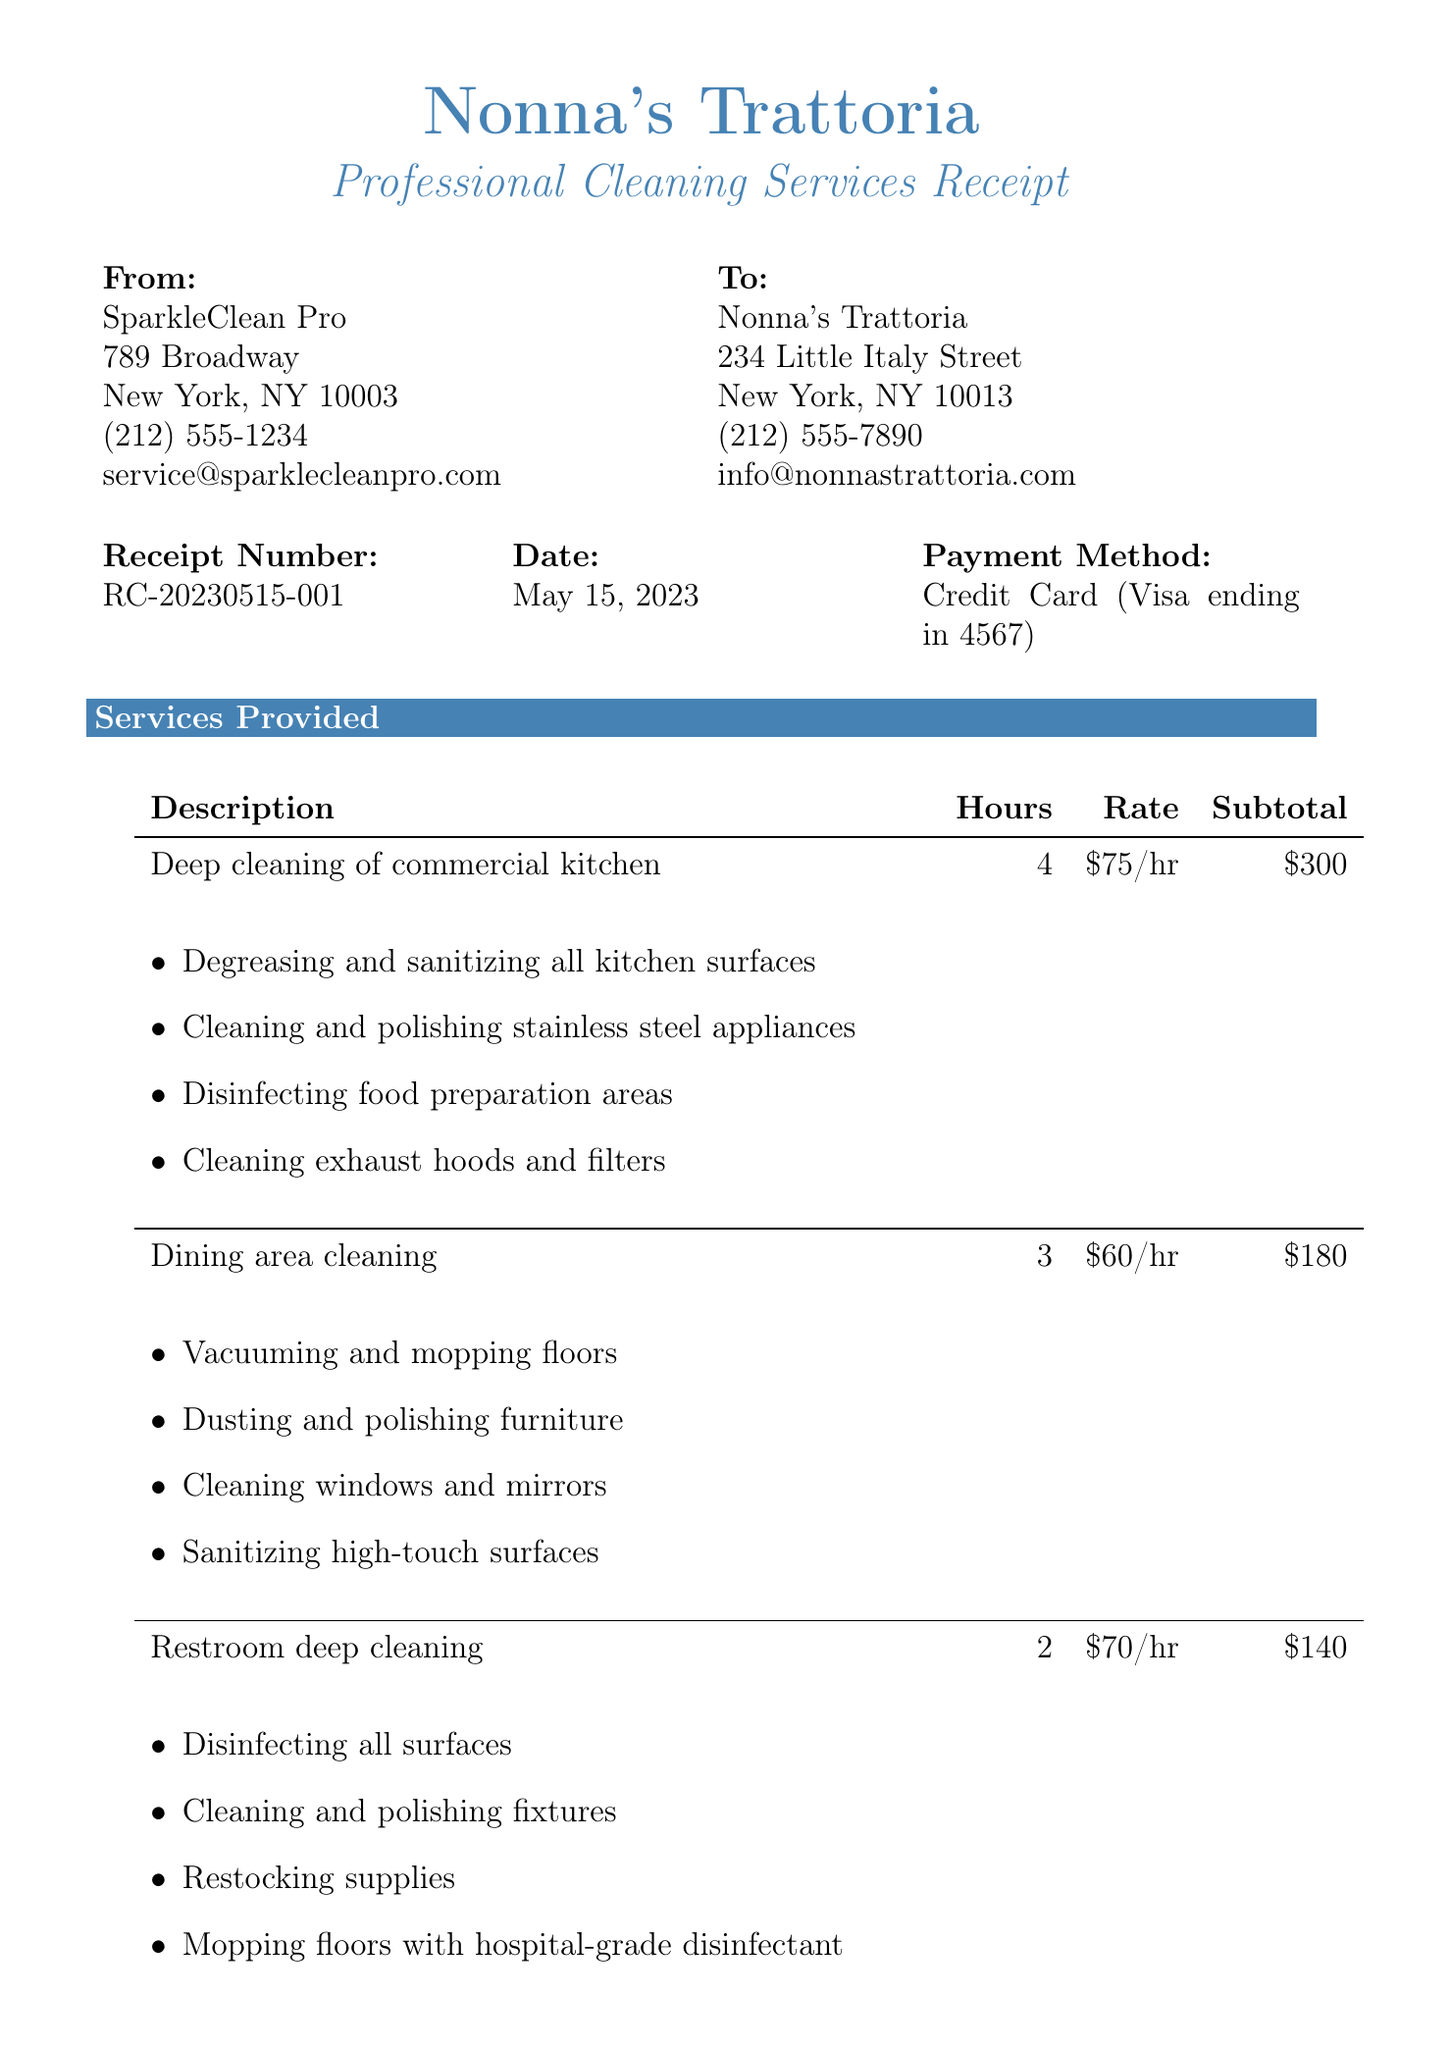What is the name of the restaurant? The name of the restaurant is listed at the top of the document.
Answer: Nonna's Trattoria What is the address of SparkleClean Pro? The address is specified in the cleaning service provider's section of the receipt.
Answer: 789 Broadway, New York, NY 10003 What is the receipt number? The receipt number is indicated in the receipt details.
Answer: RC-20230515-001 How much was charged for the dining area cleaning? The subtotal for dining area cleaning is provided in the services section of the receipt.
Answer: 180 What is the total amount charged? The total amount is stated in the totals section, which includes subtotal, additional charges, and tax.
Answer: 769.27 What percentage fee is applied for after-hours service? The fee percentage for after-hours service is noted in the additional charges section.
Answer: 10% How many hours were spent on restroom deep cleaning? The number of hours is specified for each service in the services provided section.
Answer: 2 What is the next scheduled cleaning date? The next scheduled cleaning date is mentioned in the notes section of the receipt.
Answer: June 15, 2023 Are the cleaning products used eco-friendly? The notes section indicates the type of cleaning products used.
Answer: Yes 